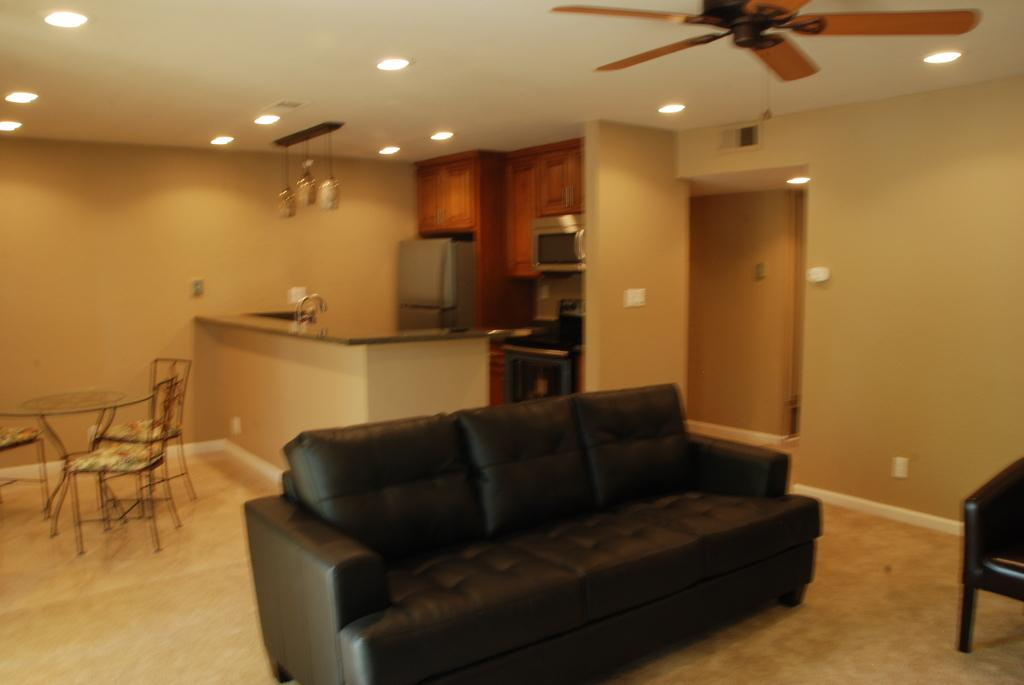What type of furniture is present in the image? There is a sofa in the image. What can be seen at the top of the image? There is a fan and ceiling lights at the top of the image. Where is the table located in the image? The table is on the left side of the image. What other seating options are available in the image? There are chairs in the image. How many clocks are hanging on the wall in the image? There are no clocks visible in the image. What type of net is used to catch the slave in the image? There is no mention of a slave or a net in the image; it features a sofa, table, chairs, a fan, and ceiling lights. 